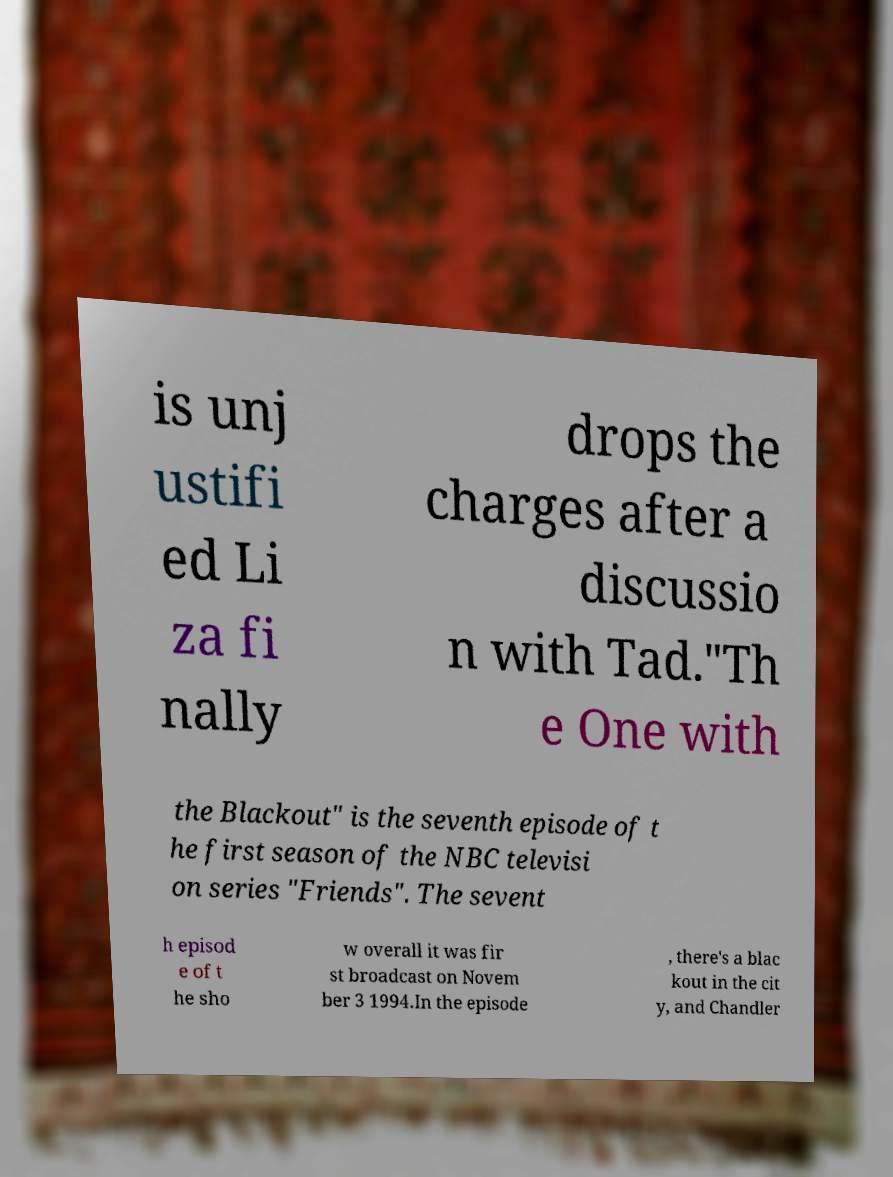Could you assist in decoding the text presented in this image and type it out clearly? is unj ustifi ed Li za fi nally drops the charges after a discussio n with Tad."Th e One with the Blackout" is the seventh episode of t he first season of the NBC televisi on series "Friends". The sevent h episod e of t he sho w overall it was fir st broadcast on Novem ber 3 1994.In the episode , there's a blac kout in the cit y, and Chandler 